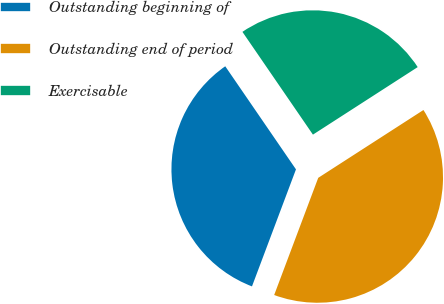Convert chart. <chart><loc_0><loc_0><loc_500><loc_500><pie_chart><fcel>Outstanding beginning of<fcel>Outstanding end of period<fcel>Exercisable<nl><fcel>34.71%<fcel>39.84%<fcel>25.46%<nl></chart> 